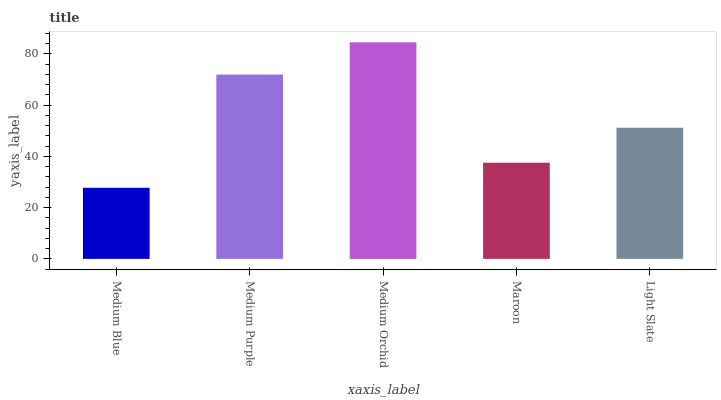Is Medium Blue the minimum?
Answer yes or no. Yes. Is Medium Orchid the maximum?
Answer yes or no. Yes. Is Medium Purple the minimum?
Answer yes or no. No. Is Medium Purple the maximum?
Answer yes or no. No. Is Medium Purple greater than Medium Blue?
Answer yes or no. Yes. Is Medium Blue less than Medium Purple?
Answer yes or no. Yes. Is Medium Blue greater than Medium Purple?
Answer yes or no. No. Is Medium Purple less than Medium Blue?
Answer yes or no. No. Is Light Slate the high median?
Answer yes or no. Yes. Is Light Slate the low median?
Answer yes or no. Yes. Is Medium Purple the high median?
Answer yes or no. No. Is Medium Purple the low median?
Answer yes or no. No. 